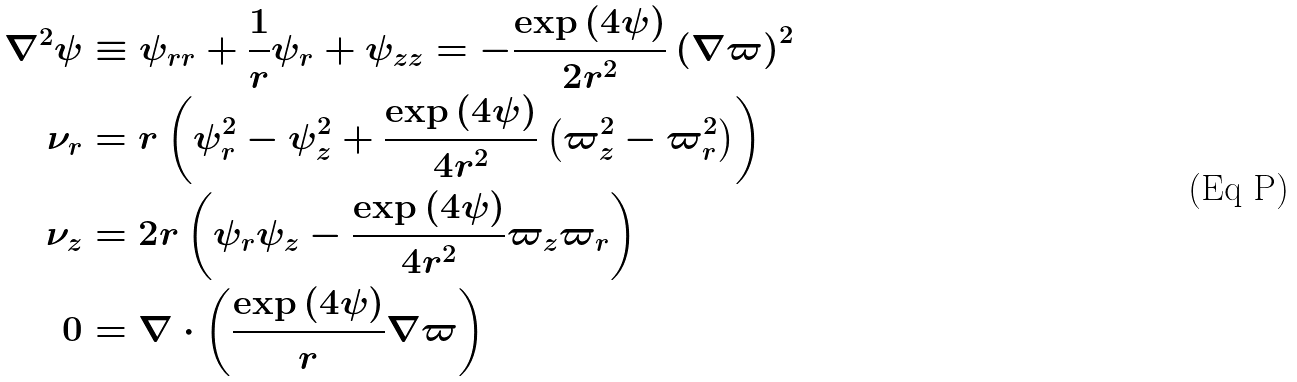<formula> <loc_0><loc_0><loc_500><loc_500>\nabla ^ { 2 } \psi & \equiv \psi _ { r r } + \frac { 1 } { r } \psi _ { r } + \psi _ { z z } = - \frac { \exp \left ( 4 \psi \right ) } { 2 r ^ { 2 } } \left ( \nabla \varpi \right ) ^ { 2 } \\ \nu _ { r } & = r \left ( \psi _ { r } ^ { 2 } - \psi _ { z } ^ { 2 } + \frac { \exp \left ( 4 \psi \right ) } { 4 r ^ { 2 } } \left ( \varpi _ { z } ^ { 2 } - \varpi _ { r } ^ { 2 } \right ) \right ) \\ \nu _ { z } & = 2 r \left ( \psi _ { r } \psi _ { z } - \frac { \exp \left ( 4 \psi \right ) } { 4 r ^ { 2 } } \varpi _ { z } \varpi _ { r } \right ) \\ 0 & = \nabla \cdot \left ( \frac { \exp \left ( 4 \psi \right ) } { r } \nabla \varpi \right )</formula> 